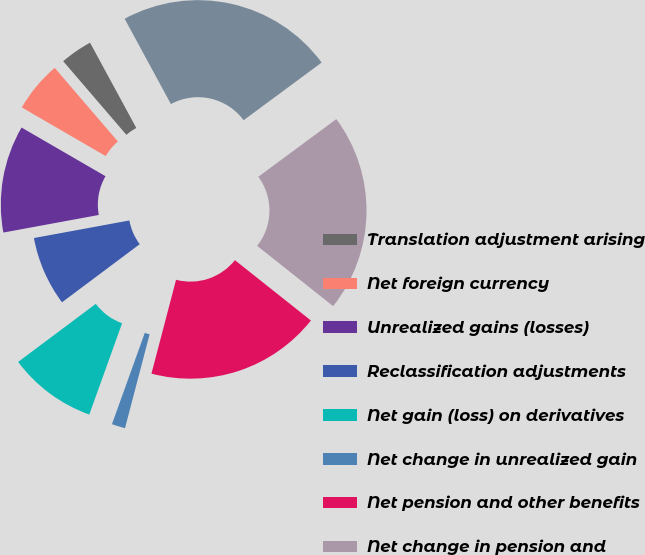Convert chart. <chart><loc_0><loc_0><loc_500><loc_500><pie_chart><fcel>Translation adjustment arising<fcel>Net foreign currency<fcel>Unrealized gains (losses)<fcel>Reclassification adjustments<fcel>Net gain (loss) on derivatives<fcel>Net change in unrealized gain<fcel>Net pension and other benefits<fcel>Net change in pension and<fcel>Other comprehensive income<nl><fcel>3.38%<fcel>5.35%<fcel>11.26%<fcel>7.32%<fcel>9.29%<fcel>1.41%<fcel>18.4%<fcel>20.81%<fcel>22.78%<nl></chart> 